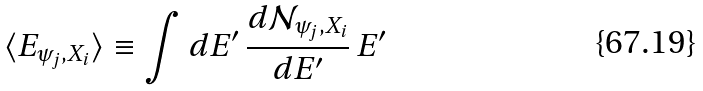<formula> <loc_0><loc_0><loc_500><loc_500>\langle E _ { \psi _ { j } , X _ { i } } \rangle \equiv \int d E ^ { \prime } \, \frac { d { \mathcal { N } } _ { \psi _ { j } , X _ { i } } } { d E ^ { \prime } } \, E ^ { \prime }</formula> 